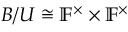<formula> <loc_0><loc_0><loc_500><loc_500>B / U \cong \mathbb { F } ^ { \times } \times \mathbb { F } ^ { \times }</formula> 